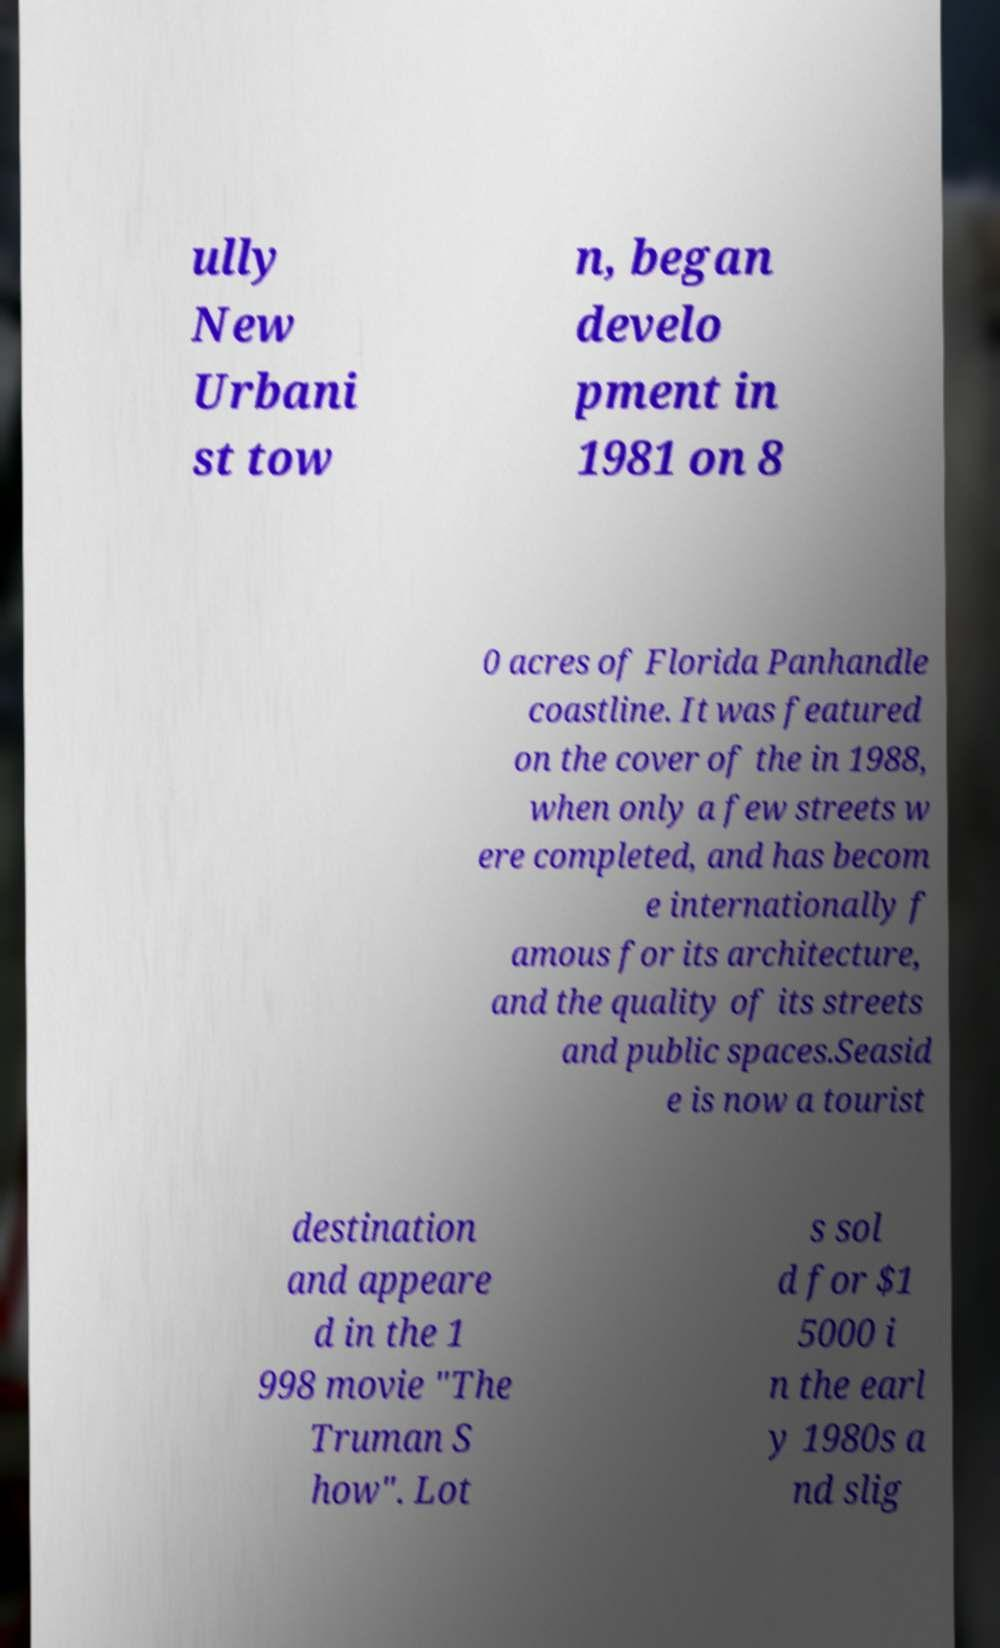I need the written content from this picture converted into text. Can you do that? ully New Urbani st tow n, began develo pment in 1981 on 8 0 acres of Florida Panhandle coastline. It was featured on the cover of the in 1988, when only a few streets w ere completed, and has becom e internationally f amous for its architecture, and the quality of its streets and public spaces.Seasid e is now a tourist destination and appeare d in the 1 998 movie "The Truman S how". Lot s sol d for $1 5000 i n the earl y 1980s a nd slig 